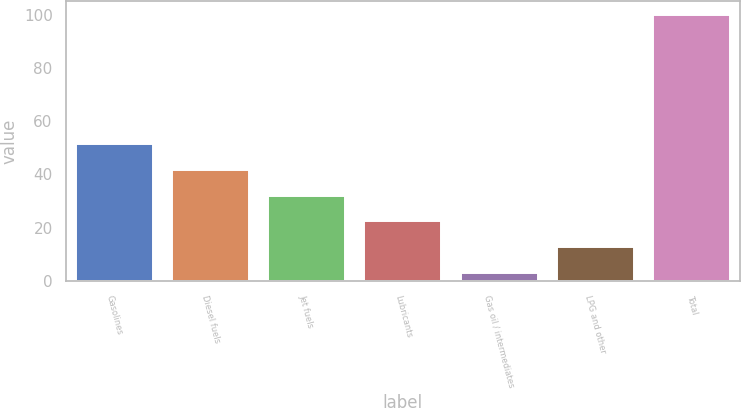<chart> <loc_0><loc_0><loc_500><loc_500><bar_chart><fcel>Gasolines<fcel>Diesel fuels<fcel>Jet fuels<fcel>Lubricants<fcel>Gas oil / intermediates<fcel>LPG and other<fcel>Total<nl><fcel>51.5<fcel>41.8<fcel>32.1<fcel>22.4<fcel>3<fcel>12.7<fcel>100<nl></chart> 